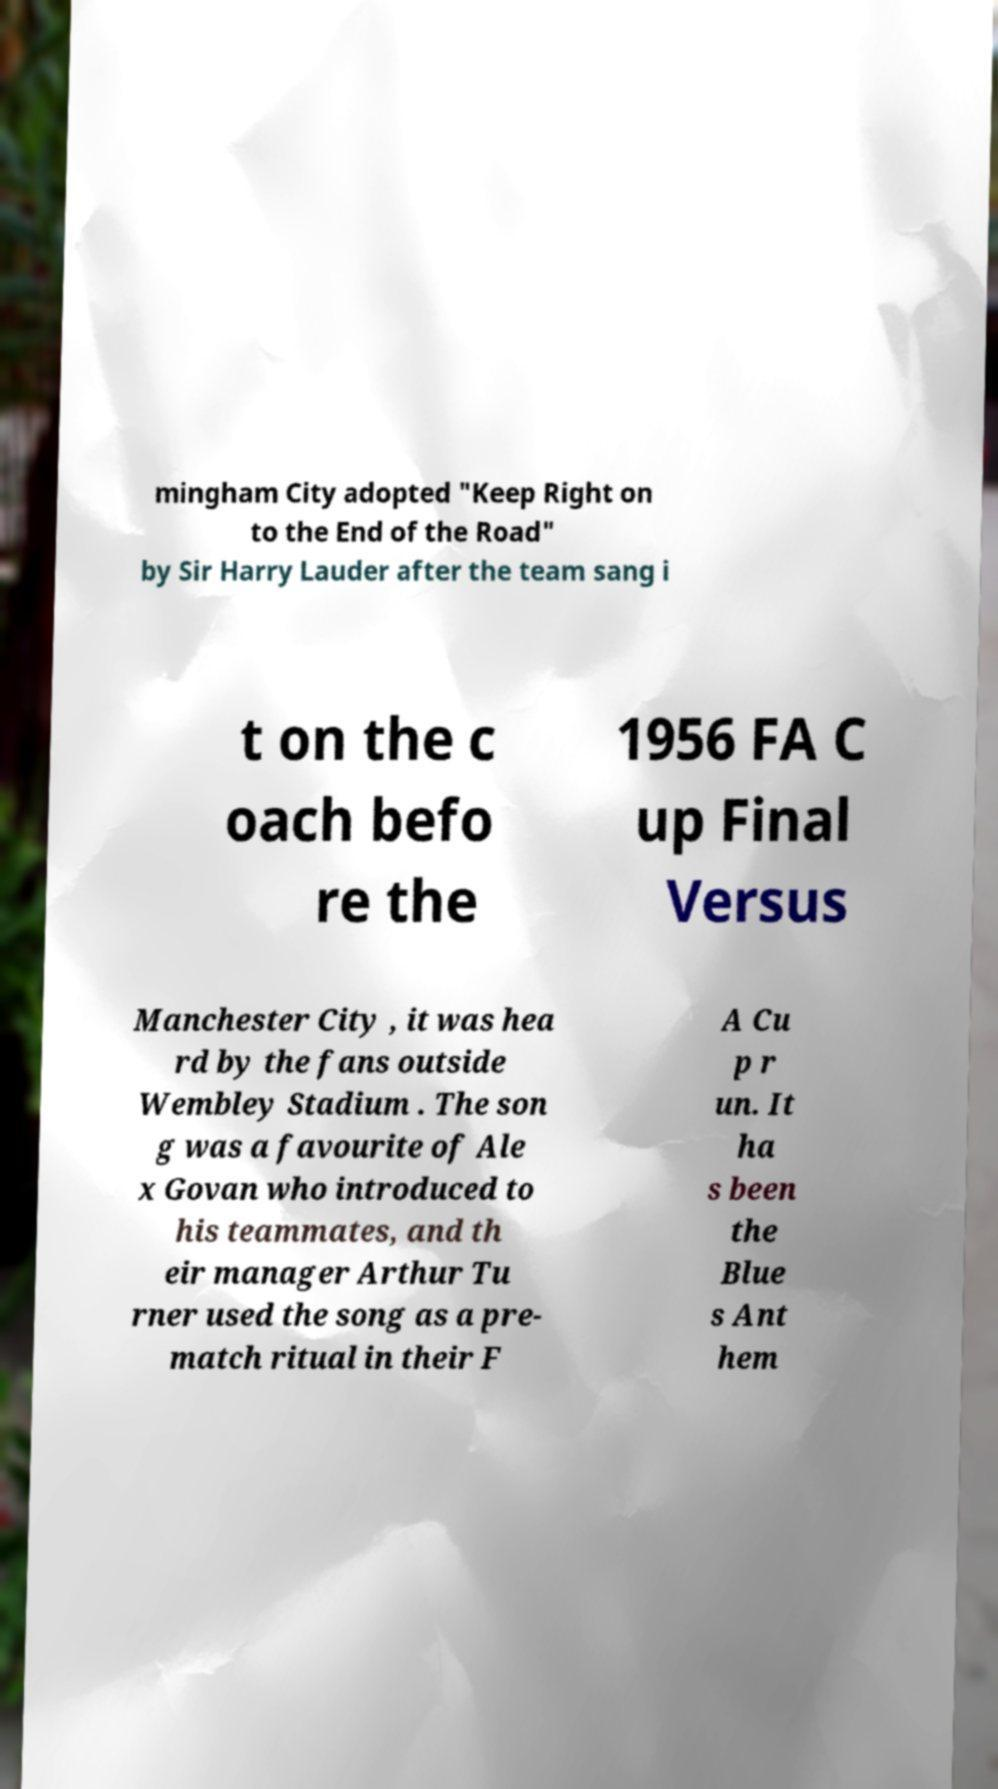I need the written content from this picture converted into text. Can you do that? mingham City adopted "Keep Right on to the End of the Road" by Sir Harry Lauder after the team sang i t on the c oach befo re the 1956 FA C up Final Versus Manchester City , it was hea rd by the fans outside Wembley Stadium . The son g was a favourite of Ale x Govan who introduced to his teammates, and th eir manager Arthur Tu rner used the song as a pre- match ritual in their F A Cu p r un. It ha s been the Blue s Ant hem 